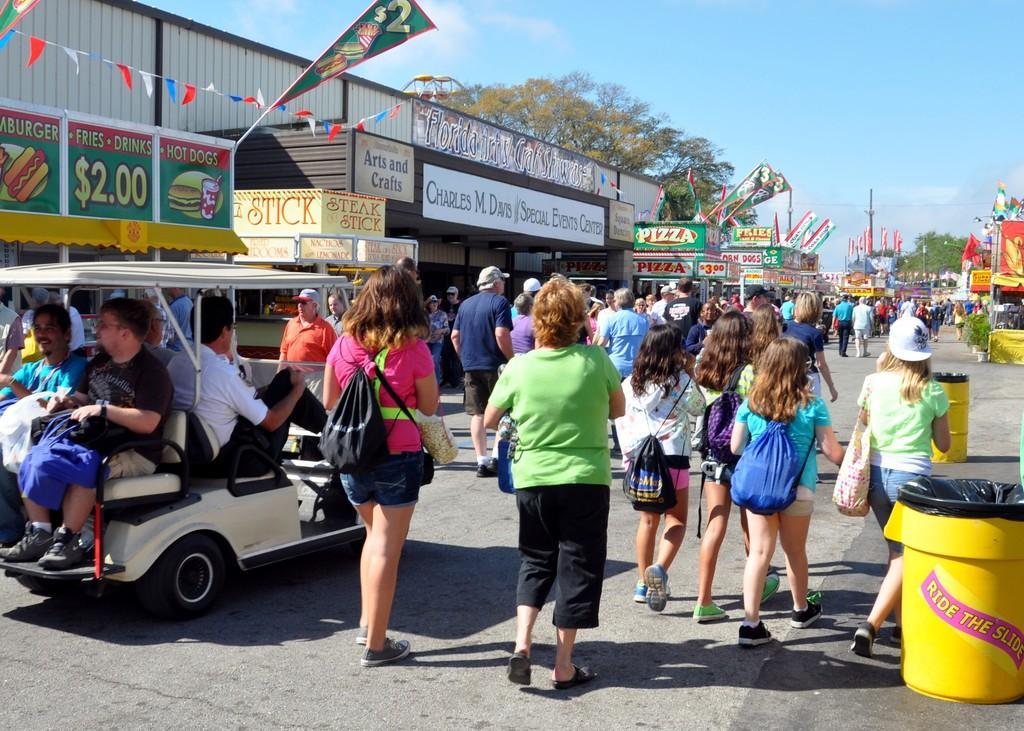Describe this image in one or two sentences. In this image there is road. There are vehicles. There are stalls on the both sides. There are trees. There is sky. 